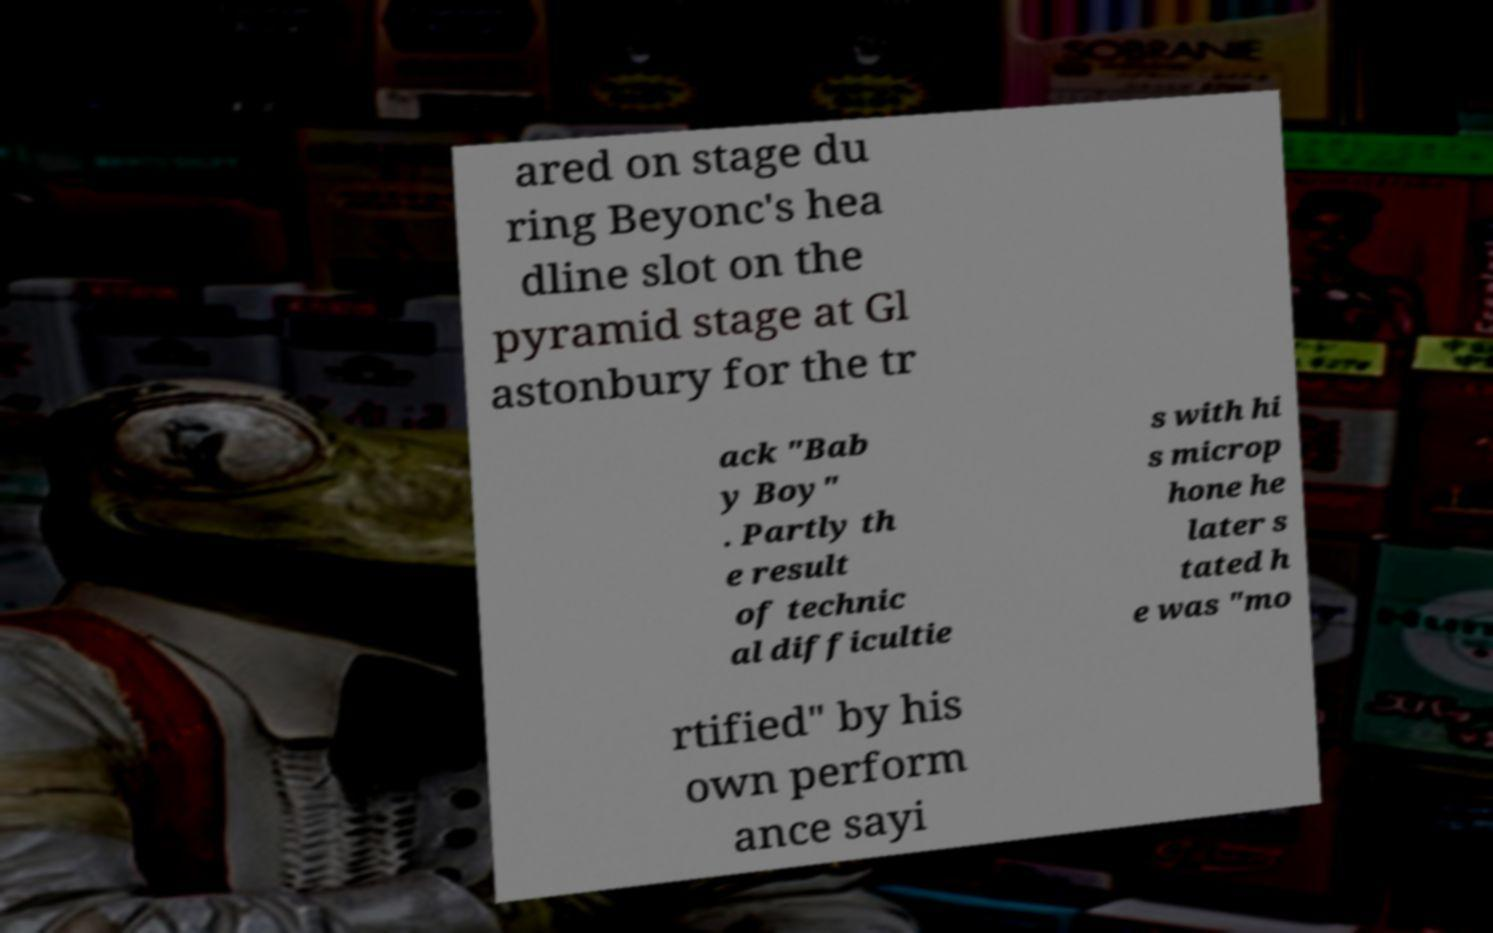Could you assist in decoding the text presented in this image and type it out clearly? ared on stage du ring Beyonc's hea dline slot on the pyramid stage at Gl astonbury for the tr ack "Bab y Boy" . Partly th e result of technic al difficultie s with hi s microp hone he later s tated h e was "mo rtified" by his own perform ance sayi 